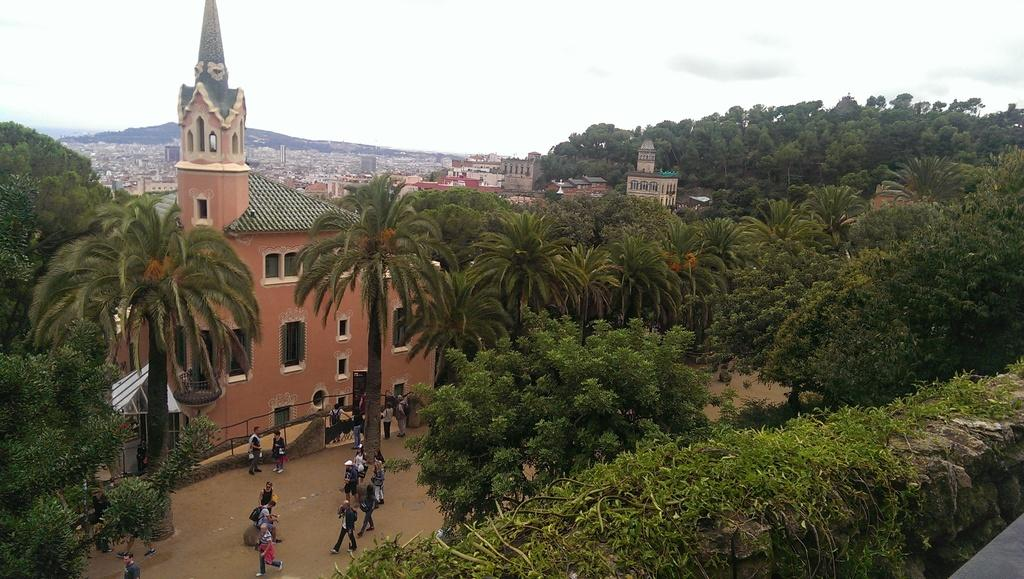What type of natural elements can be seen in the image? There are trees in the image. What type of man-made structures are present in the image? There are buildings in the image. Can you describe the people visible in the image? There are people visible on the surface in the image. What is visible in the sky in the image? Clouds are present in the sky in the image. What type of afternoon shake is being enjoyed by the people in the image? There is no reference to a shake or any food or drink in the image, so it is not possible to answer that question. 